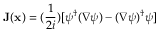Convert formula to latex. <formula><loc_0><loc_0><loc_500><loc_500>{ J } ( { x } ) = ( \frac { 1 } { 2 i } ) [ \psi ^ { \dagger } ( \nabla \psi ) - ( \nabla \psi ) ^ { \dagger } \psi ]</formula> 